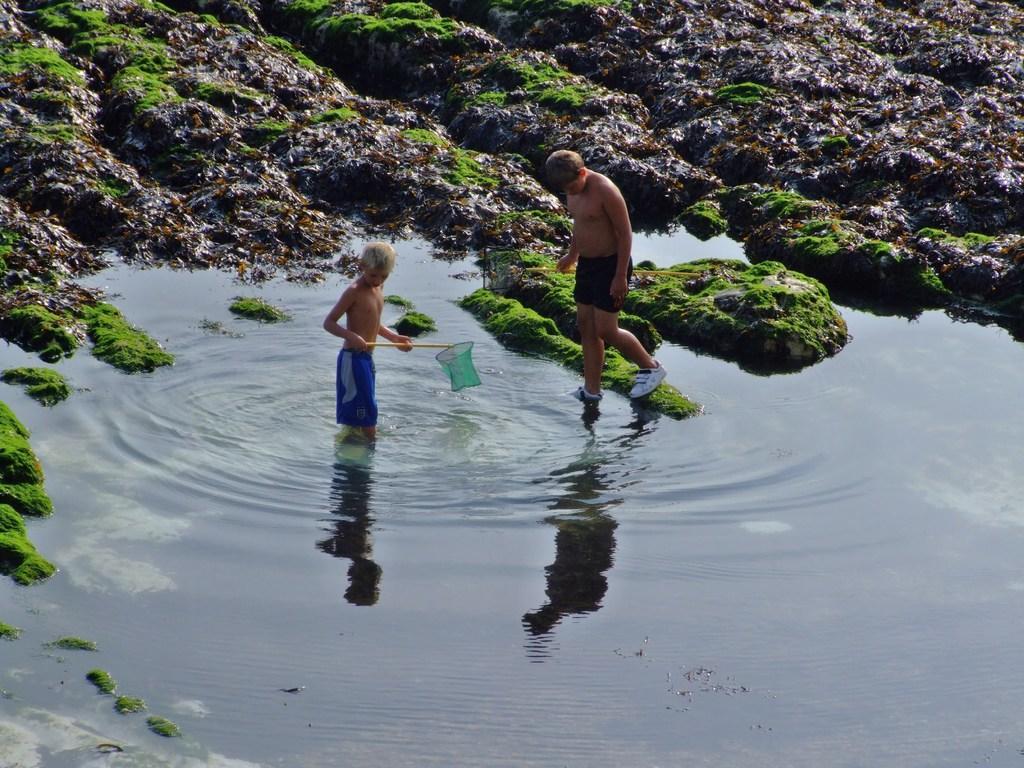In one or two sentences, can you explain what this image depicts? In this image I can see two people are standing and holding something. I can see the water,grass and rock. 